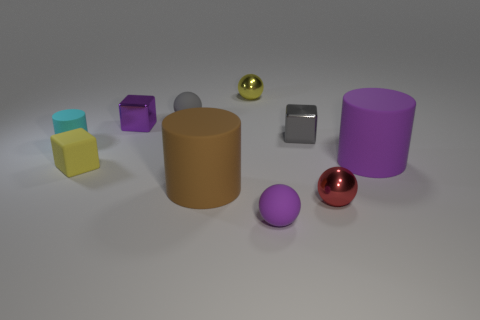How many objects are metal cylinders or tiny metallic things that are right of the gray matte object?
Provide a short and direct response. 3. Is the number of large brown matte cylinders behind the small yellow metallic sphere greater than the number of tiny green metal cylinders?
Offer a terse response. No. Are there an equal number of small cylinders right of the tiny purple matte object and large brown matte cylinders to the left of the small gray rubber ball?
Provide a succinct answer. Yes. Are there any purple metallic things right of the tiny metallic thing behind the tiny purple cube?
Ensure brevity in your answer.  No. What shape is the gray matte thing?
Provide a succinct answer. Sphere. The metallic ball that is the same color as the rubber block is what size?
Give a very brief answer. Small. How big is the thing that is left of the small yellow thing that is in front of the gray metallic cube?
Provide a short and direct response. Small. What is the size of the sphere on the left side of the brown matte cylinder?
Keep it short and to the point. Small. Is the number of small cyan cylinders that are in front of the tiny purple shiny block less than the number of large brown things behind the brown object?
Provide a succinct answer. No. The small cylinder has what color?
Offer a very short reply. Cyan. 